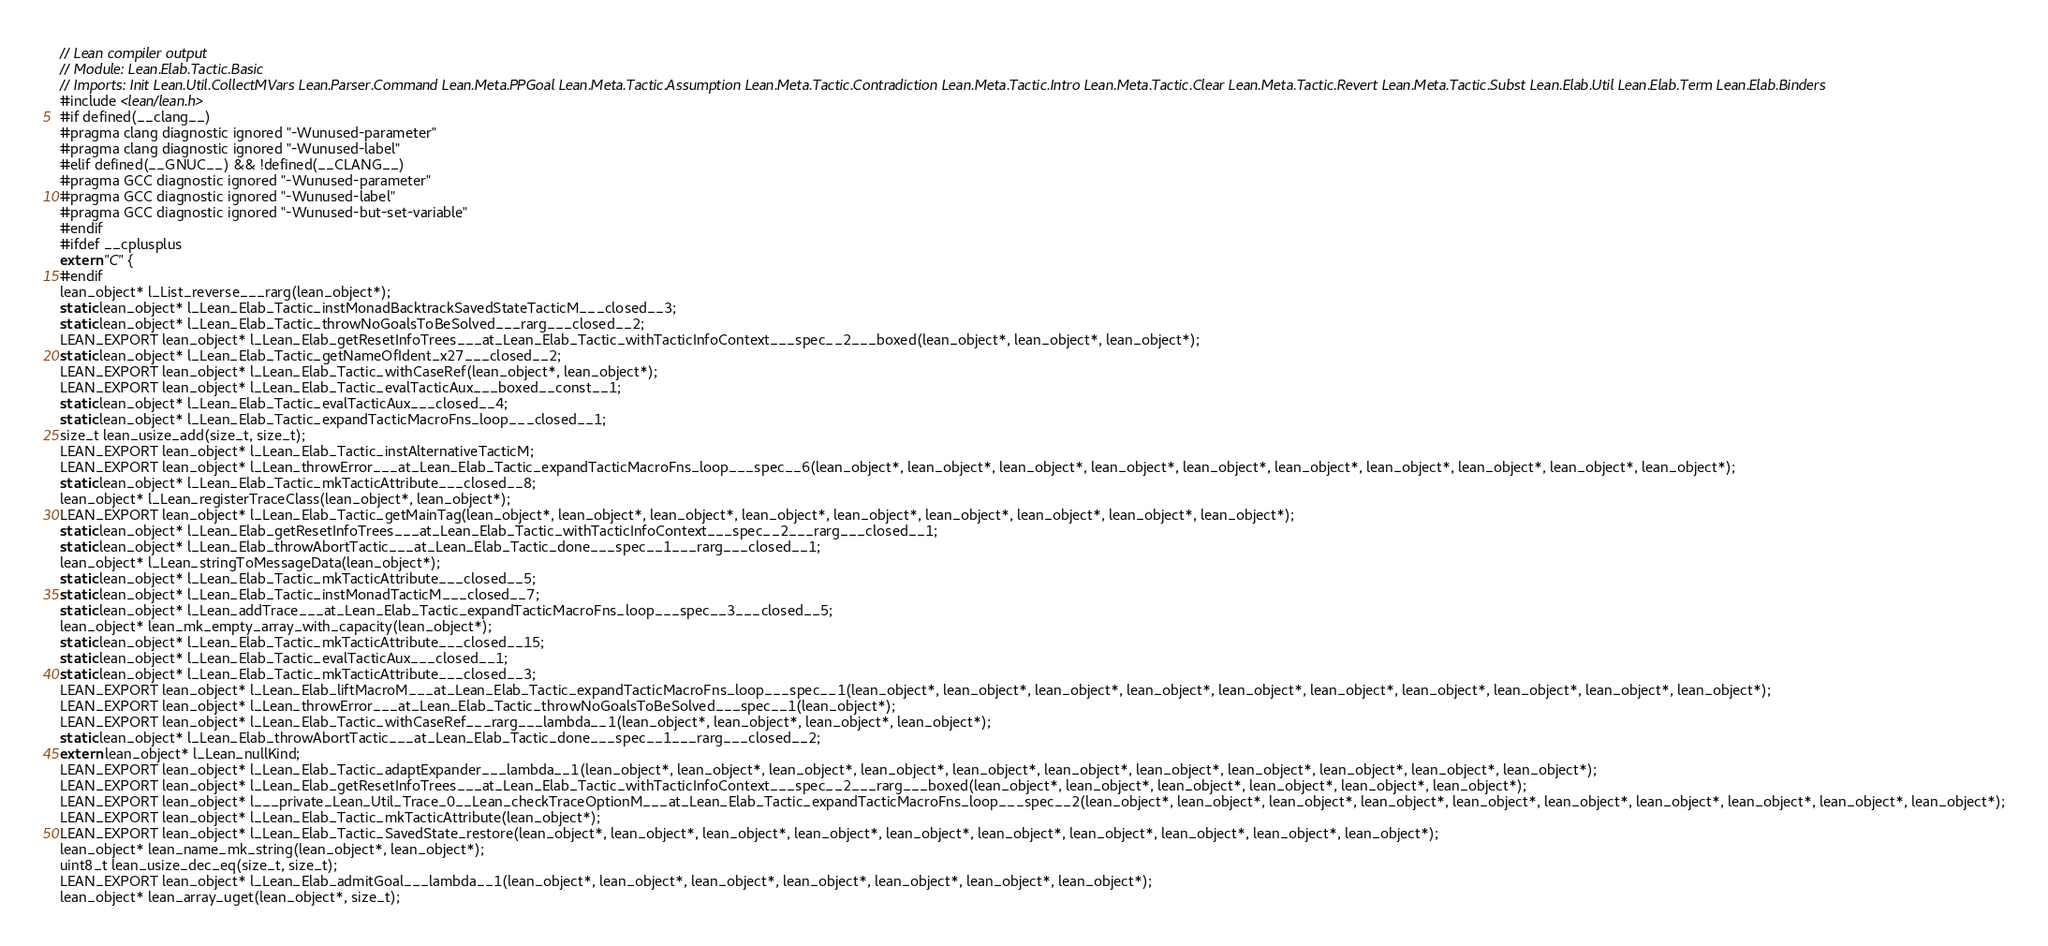<code> <loc_0><loc_0><loc_500><loc_500><_C_>// Lean compiler output
// Module: Lean.Elab.Tactic.Basic
// Imports: Init Lean.Util.CollectMVars Lean.Parser.Command Lean.Meta.PPGoal Lean.Meta.Tactic.Assumption Lean.Meta.Tactic.Contradiction Lean.Meta.Tactic.Intro Lean.Meta.Tactic.Clear Lean.Meta.Tactic.Revert Lean.Meta.Tactic.Subst Lean.Elab.Util Lean.Elab.Term Lean.Elab.Binders
#include <lean/lean.h>
#if defined(__clang__)
#pragma clang diagnostic ignored "-Wunused-parameter"
#pragma clang diagnostic ignored "-Wunused-label"
#elif defined(__GNUC__) && !defined(__CLANG__)
#pragma GCC diagnostic ignored "-Wunused-parameter"
#pragma GCC diagnostic ignored "-Wunused-label"
#pragma GCC diagnostic ignored "-Wunused-but-set-variable"
#endif
#ifdef __cplusplus
extern "C" {
#endif
lean_object* l_List_reverse___rarg(lean_object*);
static lean_object* l_Lean_Elab_Tactic_instMonadBacktrackSavedStateTacticM___closed__3;
static lean_object* l_Lean_Elab_Tactic_throwNoGoalsToBeSolved___rarg___closed__2;
LEAN_EXPORT lean_object* l_Lean_Elab_getResetInfoTrees___at_Lean_Elab_Tactic_withTacticInfoContext___spec__2___boxed(lean_object*, lean_object*, lean_object*);
static lean_object* l_Lean_Elab_Tactic_getNameOfIdent_x27___closed__2;
LEAN_EXPORT lean_object* l_Lean_Elab_Tactic_withCaseRef(lean_object*, lean_object*);
LEAN_EXPORT lean_object* l_Lean_Elab_Tactic_evalTacticAux___boxed__const__1;
static lean_object* l_Lean_Elab_Tactic_evalTacticAux___closed__4;
static lean_object* l_Lean_Elab_Tactic_expandTacticMacroFns_loop___closed__1;
size_t lean_usize_add(size_t, size_t);
LEAN_EXPORT lean_object* l_Lean_Elab_Tactic_instAlternativeTacticM;
LEAN_EXPORT lean_object* l_Lean_throwError___at_Lean_Elab_Tactic_expandTacticMacroFns_loop___spec__6(lean_object*, lean_object*, lean_object*, lean_object*, lean_object*, lean_object*, lean_object*, lean_object*, lean_object*, lean_object*);
static lean_object* l_Lean_Elab_Tactic_mkTacticAttribute___closed__8;
lean_object* l_Lean_registerTraceClass(lean_object*, lean_object*);
LEAN_EXPORT lean_object* l_Lean_Elab_Tactic_getMainTag(lean_object*, lean_object*, lean_object*, lean_object*, lean_object*, lean_object*, lean_object*, lean_object*, lean_object*);
static lean_object* l_Lean_Elab_getResetInfoTrees___at_Lean_Elab_Tactic_withTacticInfoContext___spec__2___rarg___closed__1;
static lean_object* l_Lean_Elab_throwAbortTactic___at_Lean_Elab_Tactic_done___spec__1___rarg___closed__1;
lean_object* l_Lean_stringToMessageData(lean_object*);
static lean_object* l_Lean_Elab_Tactic_mkTacticAttribute___closed__5;
static lean_object* l_Lean_Elab_Tactic_instMonadTacticM___closed__7;
static lean_object* l_Lean_addTrace___at_Lean_Elab_Tactic_expandTacticMacroFns_loop___spec__3___closed__5;
lean_object* lean_mk_empty_array_with_capacity(lean_object*);
static lean_object* l_Lean_Elab_Tactic_mkTacticAttribute___closed__15;
static lean_object* l_Lean_Elab_Tactic_evalTacticAux___closed__1;
static lean_object* l_Lean_Elab_Tactic_mkTacticAttribute___closed__3;
LEAN_EXPORT lean_object* l_Lean_Elab_liftMacroM___at_Lean_Elab_Tactic_expandTacticMacroFns_loop___spec__1(lean_object*, lean_object*, lean_object*, lean_object*, lean_object*, lean_object*, lean_object*, lean_object*, lean_object*, lean_object*);
LEAN_EXPORT lean_object* l_Lean_throwError___at_Lean_Elab_Tactic_throwNoGoalsToBeSolved___spec__1(lean_object*);
LEAN_EXPORT lean_object* l_Lean_Elab_Tactic_withCaseRef___rarg___lambda__1(lean_object*, lean_object*, lean_object*, lean_object*);
static lean_object* l_Lean_Elab_throwAbortTactic___at_Lean_Elab_Tactic_done___spec__1___rarg___closed__2;
extern lean_object* l_Lean_nullKind;
LEAN_EXPORT lean_object* l_Lean_Elab_Tactic_adaptExpander___lambda__1(lean_object*, lean_object*, lean_object*, lean_object*, lean_object*, lean_object*, lean_object*, lean_object*, lean_object*, lean_object*, lean_object*);
LEAN_EXPORT lean_object* l_Lean_Elab_getResetInfoTrees___at_Lean_Elab_Tactic_withTacticInfoContext___spec__2___rarg___boxed(lean_object*, lean_object*, lean_object*, lean_object*, lean_object*, lean_object*);
LEAN_EXPORT lean_object* l___private_Lean_Util_Trace_0__Lean_checkTraceOptionM___at_Lean_Elab_Tactic_expandTacticMacroFns_loop___spec__2(lean_object*, lean_object*, lean_object*, lean_object*, lean_object*, lean_object*, lean_object*, lean_object*, lean_object*, lean_object*);
LEAN_EXPORT lean_object* l_Lean_Elab_Tactic_mkTacticAttribute(lean_object*);
LEAN_EXPORT lean_object* l_Lean_Elab_Tactic_SavedState_restore(lean_object*, lean_object*, lean_object*, lean_object*, lean_object*, lean_object*, lean_object*, lean_object*, lean_object*, lean_object*);
lean_object* lean_name_mk_string(lean_object*, lean_object*);
uint8_t lean_usize_dec_eq(size_t, size_t);
LEAN_EXPORT lean_object* l_Lean_Elab_admitGoal___lambda__1(lean_object*, lean_object*, lean_object*, lean_object*, lean_object*, lean_object*, lean_object*);
lean_object* lean_array_uget(lean_object*, size_t);</code> 